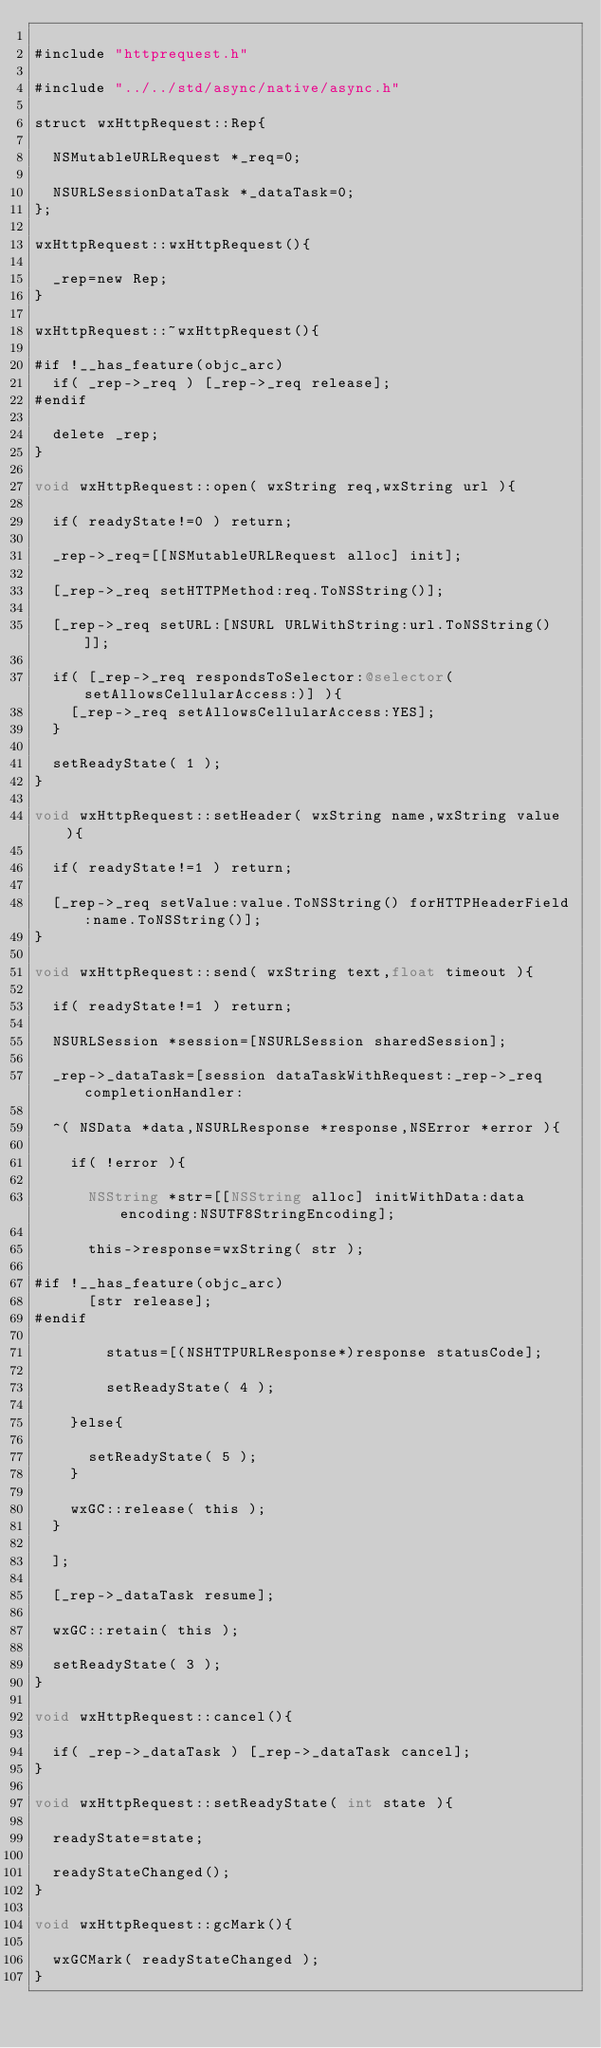Convert code to text. <code><loc_0><loc_0><loc_500><loc_500><_ObjectiveC_>
#include "httprequest.h"

#include "../../std/async/native/async.h"

struct wxHttpRequest::Rep{

	NSMutableURLRequest *_req=0;

	NSURLSessionDataTask *_dataTask=0;
};

wxHttpRequest::wxHttpRequest(){

	_rep=new Rep;
}

wxHttpRequest::~wxHttpRequest(){

#if !__has_feature(objc_arc)
	if( _rep->_req ) [_rep->_req release];
#endif

	delete _rep;
}
	
void wxHttpRequest::open( wxString req,wxString url ){
	
	if( readyState!=0 ) return;
	
	_rep->_req=[[NSMutableURLRequest alloc] init];
		
	[_rep->_req setHTTPMethod:req.ToNSString()];
	
	[_rep->_req setURL:[NSURL URLWithString:url.ToNSString()]];
	
	if( [_rep->_req respondsToSelector:@selector(setAllowsCellularAccess:)] ){
		[_rep->_req setAllowsCellularAccess:YES];
	}
	
	setReadyState( 1 );
}
	
void wxHttpRequest::setHeader( wxString name,wxString value ){
	
	if( readyState!=1 ) return;
		
	[_rep->_req setValue:value.ToNSString() forHTTPHeaderField:name.ToNSString()];
}

void wxHttpRequest::send( wxString text,float timeout ){
	
	if( readyState!=1 ) return;
	
	NSURLSession *session=[NSURLSession sharedSession];
		
	_rep->_dataTask=[session dataTaskWithRequest:_rep->_req completionHandler:
	
	^( NSData *data,NSURLResponse *response,NSError *error ){
	
		if( !error ){
		
			NSString *str=[[NSString alloc] initWithData:data encoding:NSUTF8StringEncoding];
		
			this->response=wxString( str );
			
#if !__has_feature(objc_arc)
			[str release];
#endif

		    status=[(NSHTTPURLResponse*)response statusCode];
		    
		    setReadyState( 4 );
		    
		}else{
		
			setReadyState( 5 );
		}
		
		wxGC::release( this );
	}
	
	];
	
	[_rep->_dataTask resume];

	wxGC::retain( this );
	
	setReadyState( 3 );
}

void wxHttpRequest::cancel(){

	if( _rep->_dataTask ) [_rep->_dataTask cancel];
}

void wxHttpRequest::setReadyState( int state ){

	readyState=state;
	
	readyStateChanged();
}

void wxHttpRequest::gcMark(){

	wxGCMark( readyStateChanged ); 
}

</code> 